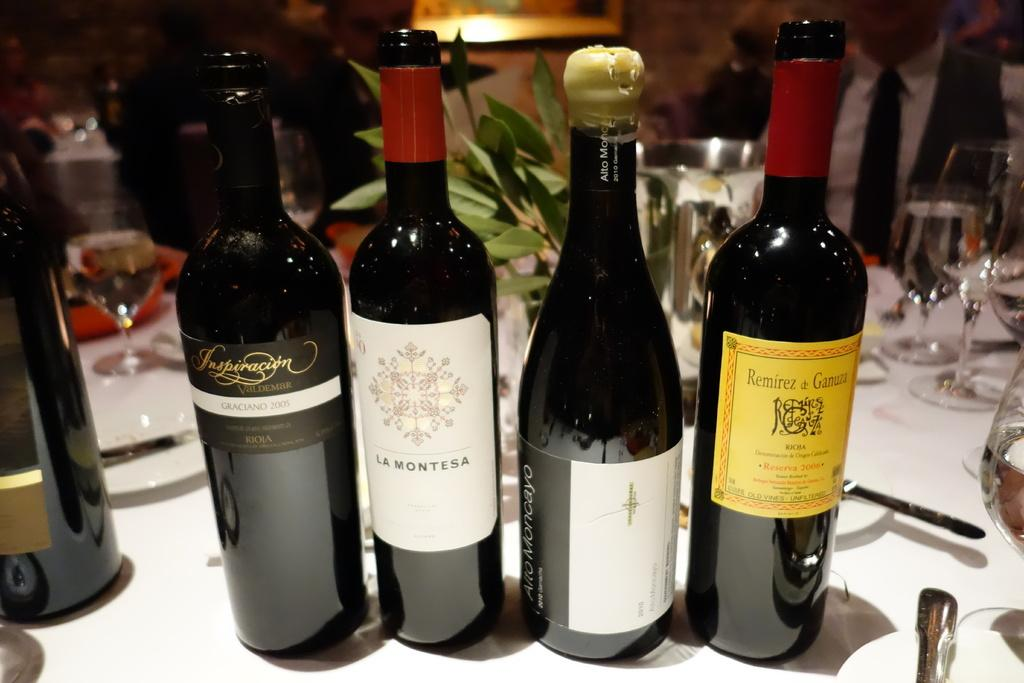<image>
Share a concise interpretation of the image provided. All of the wine bottles on the table come from regions in France. 